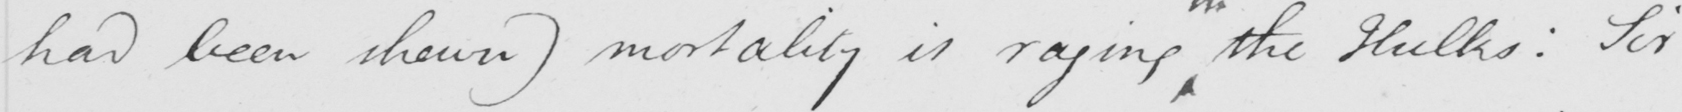Please provide the text content of this handwritten line. had been shewn )  mortality is raging the Hulks :  Sir 